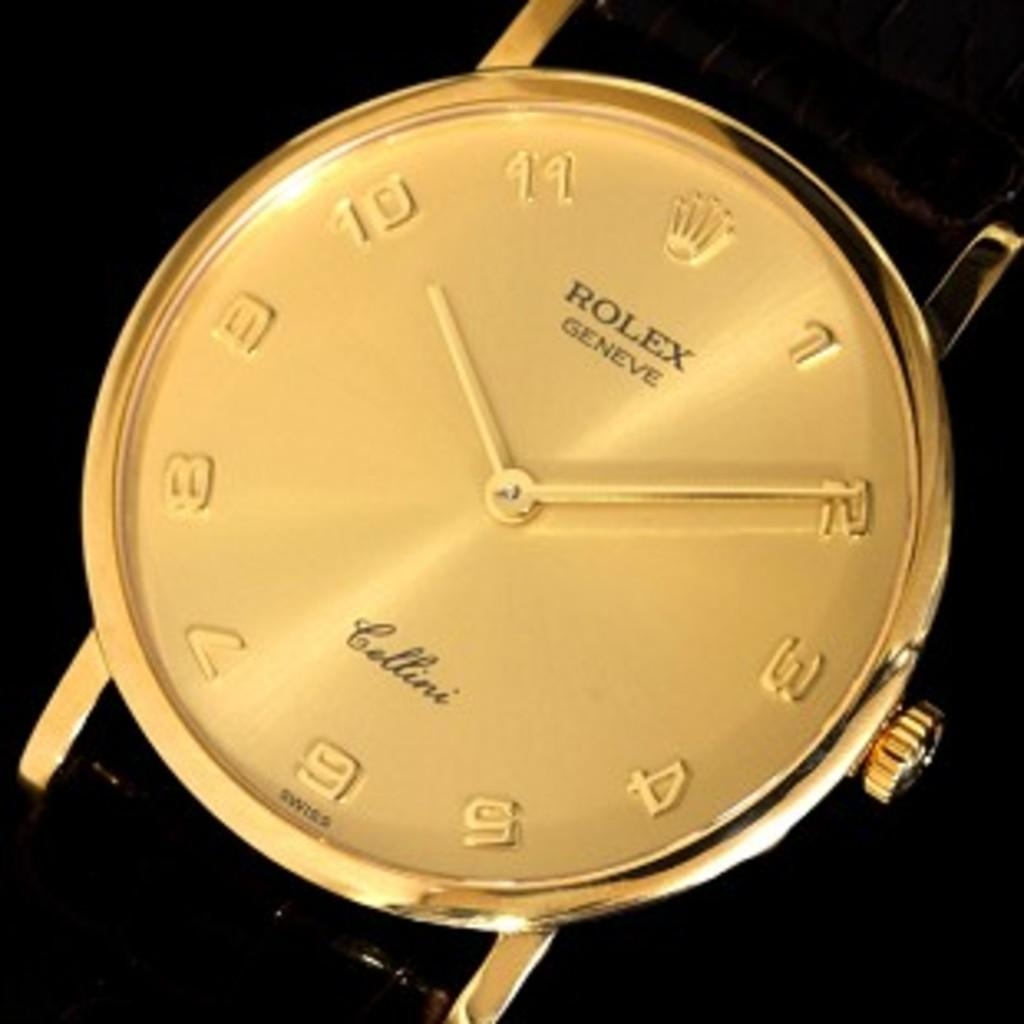Provide a one-sentence caption for the provided image. A golden Rolex watch with a black arm band. 